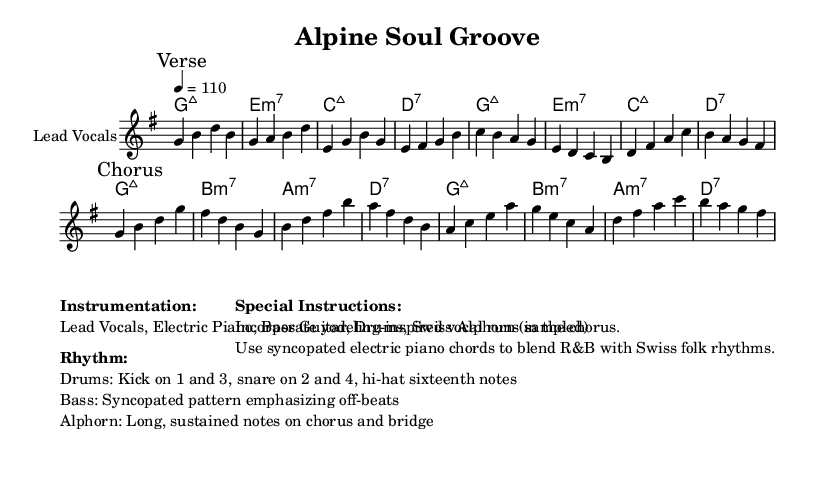What is the key signature of this music? The key signature is G major, which has one sharp (F#). This is indicated at the beginning of the sheet music under the global settings.
Answer: G major What is the time signature of this piece? The time signature is 4/4, which means there are four beats in each measure and a quarter note receives one beat. This is clearly noted in the same global settings.
Answer: 4/4 What is the tempo marking of the music? The tempo marking indicates a speed of 110 beats per minute. This is specified in the global section of the sheet music.
Answer: 110 How many measures are in the chorus section? The chorus section consists of 8 measures. Counting the measures from the start of the chorus marking to the end provides this total.
Answer: 8 What is the primary instrumentation used in this piece? The primary instrumentation includes Lead Vocals, Electric Piano, Bass Guitar, Drums, and Swiss Alphorn. This is listed in the instrumentation section of the markup.
Answer: Lead Vocals, Electric Piano, Bass Guitar, Drums, Swiss Alphorn Which element in the rhythm section emphasizes off-beats? The bass guitar employs a syncopated pattern that emphasizes off-beats, which is described in the rhythm section details of the markup.
Answer: Bass What vocal technique is suggested for the chorus? The scores suggest incorporating yodeling-inspired vocal runs during the chorus, which adds a distinctive flavor reflecting Swiss influences. This is indicated in the special instructions section.
Answer: Yodeling-inspired vocal runs 